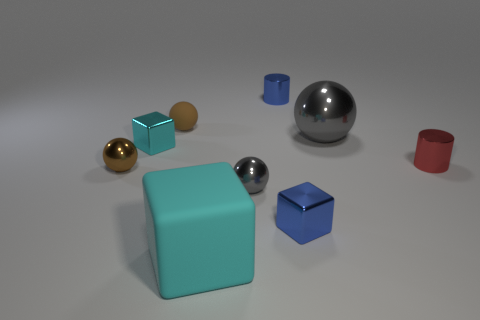What is the color of the large ball that is made of the same material as the blue cube?
Your answer should be compact. Gray. Does the big rubber cube have the same color as the small metal block left of the small gray metallic ball?
Ensure brevity in your answer.  Yes. What is the color of the shiny object that is both right of the small gray metal ball and in front of the brown metal thing?
Offer a very short reply. Blue. What number of small cyan shiny blocks are in front of the tiny gray ball?
Ensure brevity in your answer.  0. How many things are brown balls or shiny cubes on the right side of the big cyan rubber thing?
Your answer should be compact. 3. There is a cyan cube that is right of the brown rubber object; is there a cyan cube in front of it?
Keep it short and to the point. No. There is a tiny block in front of the small red metal cylinder; what is its color?
Make the answer very short. Blue. Is the number of large gray spheres right of the big gray shiny thing the same as the number of gray metal things?
Provide a short and direct response. No. What is the shape of the small metal thing that is in front of the small red shiny cylinder and on the left side of the large cyan matte object?
Make the answer very short. Sphere. There is another rubber object that is the same shape as the big gray thing; what color is it?
Offer a terse response. Brown. 